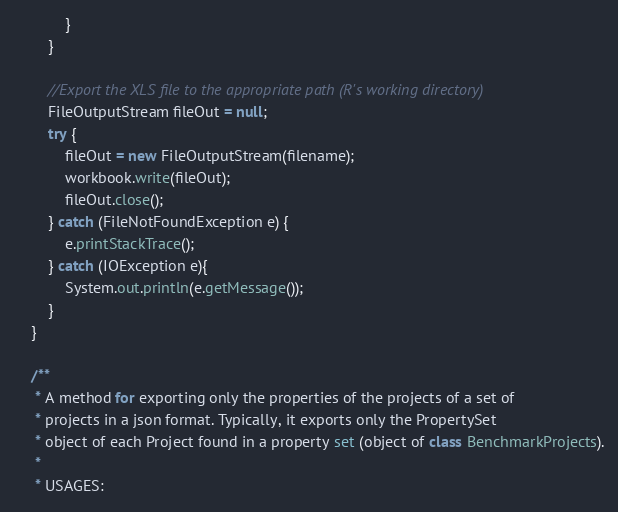Convert code to text. <code><loc_0><loc_0><loc_500><loc_500><_Java_>
            }
        }

        //Export the XLS file to the appropriate path (R's working directory)
        FileOutputStream fileOut = null;
        try {
            fileOut = new FileOutputStream(filename);
            workbook.write(fileOut);
            fileOut.close();
        } catch (FileNotFoundException e) {
            e.printStackTrace();
        } catch (IOException e){
            System.out.println(e.getMessage());
        }
    }

    /**
     * A method for exporting only the properties of the projects of a set of
     * projects in a json format. Typically, it exports only the PropertySet
     * object of each Project found in a property set (object of class BenchmarkProjects).
     *
     * USAGES:</code> 